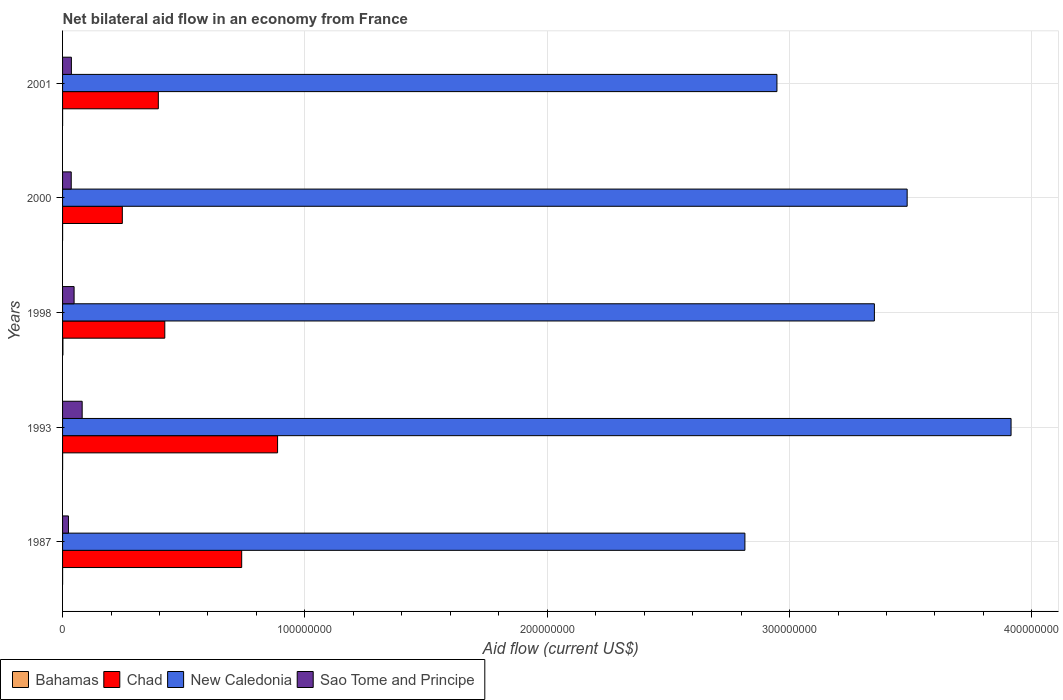How many different coloured bars are there?
Provide a succinct answer. 4. Are the number of bars on each tick of the Y-axis equal?
Make the answer very short. Yes. How many bars are there on the 5th tick from the bottom?
Provide a short and direct response. 4. In how many cases, is the number of bars for a given year not equal to the number of legend labels?
Offer a terse response. 0. What is the net bilateral aid flow in Chad in 2001?
Keep it short and to the point. 3.95e+07. Across all years, what is the maximum net bilateral aid flow in Sao Tome and Principe?
Offer a terse response. 8.09e+06. In which year was the net bilateral aid flow in Bahamas maximum?
Make the answer very short. 1998. What is the total net bilateral aid flow in Sao Tome and Principe in the graph?
Your answer should be very brief. 2.25e+07. What is the difference between the net bilateral aid flow in New Caledonia in 1993 and that in 1998?
Provide a short and direct response. 5.64e+07. What is the difference between the net bilateral aid flow in Chad in 1993 and the net bilateral aid flow in Bahamas in 2000?
Give a very brief answer. 8.87e+07. In the year 1993, what is the difference between the net bilateral aid flow in Chad and net bilateral aid flow in New Caledonia?
Give a very brief answer. -3.03e+08. What is the ratio of the net bilateral aid flow in Sao Tome and Principe in 1998 to that in 2000?
Offer a very short reply. 1.33. Is the net bilateral aid flow in Sao Tome and Principe in 1987 less than that in 1993?
Provide a short and direct response. Yes. What is the difference between the highest and the second highest net bilateral aid flow in Bahamas?
Make the answer very short. 1.30e+05. What is the difference between the highest and the lowest net bilateral aid flow in Sao Tome and Principe?
Make the answer very short. 5.66e+06. Is it the case that in every year, the sum of the net bilateral aid flow in Chad and net bilateral aid flow in New Caledonia is greater than the sum of net bilateral aid flow in Sao Tome and Principe and net bilateral aid flow in Bahamas?
Your answer should be compact. No. What does the 4th bar from the top in 1987 represents?
Offer a very short reply. Bahamas. What does the 4th bar from the bottom in 2001 represents?
Your response must be concise. Sao Tome and Principe. Is it the case that in every year, the sum of the net bilateral aid flow in Chad and net bilateral aid flow in New Caledonia is greater than the net bilateral aid flow in Bahamas?
Provide a succinct answer. Yes. How many bars are there?
Ensure brevity in your answer.  20. How many years are there in the graph?
Keep it short and to the point. 5. Are the values on the major ticks of X-axis written in scientific E-notation?
Your answer should be compact. No. How are the legend labels stacked?
Your response must be concise. Horizontal. What is the title of the graph?
Your answer should be very brief. Net bilateral aid flow in an economy from France. What is the Aid flow (current US$) in Chad in 1987?
Your answer should be very brief. 7.39e+07. What is the Aid flow (current US$) in New Caledonia in 1987?
Keep it short and to the point. 2.82e+08. What is the Aid flow (current US$) of Sao Tome and Principe in 1987?
Ensure brevity in your answer.  2.43e+06. What is the Aid flow (current US$) of Chad in 1993?
Your answer should be compact. 8.87e+07. What is the Aid flow (current US$) of New Caledonia in 1993?
Provide a succinct answer. 3.91e+08. What is the Aid flow (current US$) in Sao Tome and Principe in 1993?
Keep it short and to the point. 8.09e+06. What is the Aid flow (current US$) of Chad in 1998?
Provide a succinct answer. 4.22e+07. What is the Aid flow (current US$) in New Caledonia in 1998?
Ensure brevity in your answer.  3.35e+08. What is the Aid flow (current US$) in Sao Tome and Principe in 1998?
Keep it short and to the point. 4.76e+06. What is the Aid flow (current US$) in Chad in 2000?
Make the answer very short. 2.47e+07. What is the Aid flow (current US$) in New Caledonia in 2000?
Provide a short and direct response. 3.49e+08. What is the Aid flow (current US$) in Sao Tome and Principe in 2000?
Provide a short and direct response. 3.58e+06. What is the Aid flow (current US$) of Bahamas in 2001?
Offer a very short reply. 10000. What is the Aid flow (current US$) in Chad in 2001?
Offer a very short reply. 3.95e+07. What is the Aid flow (current US$) in New Caledonia in 2001?
Make the answer very short. 2.95e+08. What is the Aid flow (current US$) in Sao Tome and Principe in 2001?
Offer a terse response. 3.64e+06. Across all years, what is the maximum Aid flow (current US$) of Bahamas?
Make the answer very short. 1.50e+05. Across all years, what is the maximum Aid flow (current US$) of Chad?
Offer a very short reply. 8.87e+07. Across all years, what is the maximum Aid flow (current US$) in New Caledonia?
Keep it short and to the point. 3.91e+08. Across all years, what is the maximum Aid flow (current US$) of Sao Tome and Principe?
Your answer should be compact. 8.09e+06. Across all years, what is the minimum Aid flow (current US$) in Bahamas?
Provide a succinct answer. 10000. Across all years, what is the minimum Aid flow (current US$) of Chad?
Your response must be concise. 2.47e+07. Across all years, what is the minimum Aid flow (current US$) in New Caledonia?
Provide a succinct answer. 2.82e+08. Across all years, what is the minimum Aid flow (current US$) in Sao Tome and Principe?
Provide a succinct answer. 2.43e+06. What is the total Aid flow (current US$) in Bahamas in the graph?
Offer a terse response. 2.00e+05. What is the total Aid flow (current US$) of Chad in the graph?
Give a very brief answer. 2.69e+08. What is the total Aid flow (current US$) in New Caledonia in the graph?
Provide a short and direct response. 1.65e+09. What is the total Aid flow (current US$) in Sao Tome and Principe in the graph?
Your response must be concise. 2.25e+07. What is the difference between the Aid flow (current US$) of Chad in 1987 and that in 1993?
Provide a succinct answer. -1.48e+07. What is the difference between the Aid flow (current US$) of New Caledonia in 1987 and that in 1993?
Provide a short and direct response. -1.10e+08. What is the difference between the Aid flow (current US$) of Sao Tome and Principe in 1987 and that in 1993?
Provide a short and direct response. -5.66e+06. What is the difference between the Aid flow (current US$) of Bahamas in 1987 and that in 1998?
Offer a very short reply. -1.40e+05. What is the difference between the Aid flow (current US$) in Chad in 1987 and that in 1998?
Ensure brevity in your answer.  3.17e+07. What is the difference between the Aid flow (current US$) in New Caledonia in 1987 and that in 1998?
Ensure brevity in your answer.  -5.34e+07. What is the difference between the Aid flow (current US$) in Sao Tome and Principe in 1987 and that in 1998?
Keep it short and to the point. -2.33e+06. What is the difference between the Aid flow (current US$) of Chad in 1987 and that in 2000?
Your answer should be very brief. 4.93e+07. What is the difference between the Aid flow (current US$) in New Caledonia in 1987 and that in 2000?
Provide a short and direct response. -6.70e+07. What is the difference between the Aid flow (current US$) of Sao Tome and Principe in 1987 and that in 2000?
Keep it short and to the point. -1.15e+06. What is the difference between the Aid flow (current US$) in Chad in 1987 and that in 2001?
Ensure brevity in your answer.  3.44e+07. What is the difference between the Aid flow (current US$) of New Caledonia in 1987 and that in 2001?
Offer a very short reply. -1.32e+07. What is the difference between the Aid flow (current US$) of Sao Tome and Principe in 1987 and that in 2001?
Offer a terse response. -1.21e+06. What is the difference between the Aid flow (current US$) of Bahamas in 1993 and that in 1998?
Offer a very short reply. -1.30e+05. What is the difference between the Aid flow (current US$) in Chad in 1993 and that in 1998?
Make the answer very short. 4.65e+07. What is the difference between the Aid flow (current US$) of New Caledonia in 1993 and that in 1998?
Keep it short and to the point. 5.64e+07. What is the difference between the Aid flow (current US$) in Sao Tome and Principe in 1993 and that in 1998?
Provide a short and direct response. 3.33e+06. What is the difference between the Aid flow (current US$) in Bahamas in 1993 and that in 2000?
Make the answer very short. 10000. What is the difference between the Aid flow (current US$) of Chad in 1993 and that in 2000?
Ensure brevity in your answer.  6.41e+07. What is the difference between the Aid flow (current US$) of New Caledonia in 1993 and that in 2000?
Provide a succinct answer. 4.29e+07. What is the difference between the Aid flow (current US$) of Sao Tome and Principe in 1993 and that in 2000?
Make the answer very short. 4.51e+06. What is the difference between the Aid flow (current US$) in Bahamas in 1993 and that in 2001?
Offer a very short reply. 10000. What is the difference between the Aid flow (current US$) in Chad in 1993 and that in 2001?
Provide a short and direct response. 4.92e+07. What is the difference between the Aid flow (current US$) in New Caledonia in 1993 and that in 2001?
Keep it short and to the point. 9.66e+07. What is the difference between the Aid flow (current US$) in Sao Tome and Principe in 1993 and that in 2001?
Give a very brief answer. 4.45e+06. What is the difference between the Aid flow (current US$) of Chad in 1998 and that in 2000?
Provide a succinct answer. 1.75e+07. What is the difference between the Aid flow (current US$) in New Caledonia in 1998 and that in 2000?
Offer a very short reply. -1.35e+07. What is the difference between the Aid flow (current US$) in Sao Tome and Principe in 1998 and that in 2000?
Your answer should be compact. 1.18e+06. What is the difference between the Aid flow (current US$) of Bahamas in 1998 and that in 2001?
Provide a short and direct response. 1.40e+05. What is the difference between the Aid flow (current US$) in Chad in 1998 and that in 2001?
Provide a short and direct response. 2.67e+06. What is the difference between the Aid flow (current US$) of New Caledonia in 1998 and that in 2001?
Your answer should be compact. 4.02e+07. What is the difference between the Aid flow (current US$) in Sao Tome and Principe in 1998 and that in 2001?
Your response must be concise. 1.12e+06. What is the difference between the Aid flow (current US$) in Chad in 2000 and that in 2001?
Ensure brevity in your answer.  -1.49e+07. What is the difference between the Aid flow (current US$) of New Caledonia in 2000 and that in 2001?
Your answer should be very brief. 5.37e+07. What is the difference between the Aid flow (current US$) in Sao Tome and Principe in 2000 and that in 2001?
Make the answer very short. -6.00e+04. What is the difference between the Aid flow (current US$) in Bahamas in 1987 and the Aid flow (current US$) in Chad in 1993?
Give a very brief answer. -8.87e+07. What is the difference between the Aid flow (current US$) of Bahamas in 1987 and the Aid flow (current US$) of New Caledonia in 1993?
Keep it short and to the point. -3.91e+08. What is the difference between the Aid flow (current US$) in Bahamas in 1987 and the Aid flow (current US$) in Sao Tome and Principe in 1993?
Ensure brevity in your answer.  -8.08e+06. What is the difference between the Aid flow (current US$) in Chad in 1987 and the Aid flow (current US$) in New Caledonia in 1993?
Make the answer very short. -3.18e+08. What is the difference between the Aid flow (current US$) of Chad in 1987 and the Aid flow (current US$) of Sao Tome and Principe in 1993?
Your response must be concise. 6.58e+07. What is the difference between the Aid flow (current US$) in New Caledonia in 1987 and the Aid flow (current US$) in Sao Tome and Principe in 1993?
Offer a very short reply. 2.73e+08. What is the difference between the Aid flow (current US$) of Bahamas in 1987 and the Aid flow (current US$) of Chad in 1998?
Make the answer very short. -4.22e+07. What is the difference between the Aid flow (current US$) of Bahamas in 1987 and the Aid flow (current US$) of New Caledonia in 1998?
Ensure brevity in your answer.  -3.35e+08. What is the difference between the Aid flow (current US$) in Bahamas in 1987 and the Aid flow (current US$) in Sao Tome and Principe in 1998?
Your response must be concise. -4.75e+06. What is the difference between the Aid flow (current US$) of Chad in 1987 and the Aid flow (current US$) of New Caledonia in 1998?
Give a very brief answer. -2.61e+08. What is the difference between the Aid flow (current US$) of Chad in 1987 and the Aid flow (current US$) of Sao Tome and Principe in 1998?
Your response must be concise. 6.92e+07. What is the difference between the Aid flow (current US$) of New Caledonia in 1987 and the Aid flow (current US$) of Sao Tome and Principe in 1998?
Offer a terse response. 2.77e+08. What is the difference between the Aid flow (current US$) of Bahamas in 1987 and the Aid flow (current US$) of Chad in 2000?
Your response must be concise. -2.46e+07. What is the difference between the Aid flow (current US$) in Bahamas in 1987 and the Aid flow (current US$) in New Caledonia in 2000?
Your answer should be compact. -3.49e+08. What is the difference between the Aid flow (current US$) in Bahamas in 1987 and the Aid flow (current US$) in Sao Tome and Principe in 2000?
Provide a short and direct response. -3.57e+06. What is the difference between the Aid flow (current US$) in Chad in 1987 and the Aid flow (current US$) in New Caledonia in 2000?
Provide a short and direct response. -2.75e+08. What is the difference between the Aid flow (current US$) in Chad in 1987 and the Aid flow (current US$) in Sao Tome and Principe in 2000?
Your response must be concise. 7.03e+07. What is the difference between the Aid flow (current US$) in New Caledonia in 1987 and the Aid flow (current US$) in Sao Tome and Principe in 2000?
Keep it short and to the point. 2.78e+08. What is the difference between the Aid flow (current US$) of Bahamas in 1987 and the Aid flow (current US$) of Chad in 2001?
Ensure brevity in your answer.  -3.95e+07. What is the difference between the Aid flow (current US$) of Bahamas in 1987 and the Aid flow (current US$) of New Caledonia in 2001?
Ensure brevity in your answer.  -2.95e+08. What is the difference between the Aid flow (current US$) of Bahamas in 1987 and the Aid flow (current US$) of Sao Tome and Principe in 2001?
Give a very brief answer. -3.63e+06. What is the difference between the Aid flow (current US$) in Chad in 1987 and the Aid flow (current US$) in New Caledonia in 2001?
Ensure brevity in your answer.  -2.21e+08. What is the difference between the Aid flow (current US$) of Chad in 1987 and the Aid flow (current US$) of Sao Tome and Principe in 2001?
Give a very brief answer. 7.03e+07. What is the difference between the Aid flow (current US$) of New Caledonia in 1987 and the Aid flow (current US$) of Sao Tome and Principe in 2001?
Your response must be concise. 2.78e+08. What is the difference between the Aid flow (current US$) in Bahamas in 1993 and the Aid flow (current US$) in Chad in 1998?
Provide a succinct answer. -4.22e+07. What is the difference between the Aid flow (current US$) of Bahamas in 1993 and the Aid flow (current US$) of New Caledonia in 1998?
Give a very brief answer. -3.35e+08. What is the difference between the Aid flow (current US$) in Bahamas in 1993 and the Aid flow (current US$) in Sao Tome and Principe in 1998?
Your answer should be compact. -4.74e+06. What is the difference between the Aid flow (current US$) in Chad in 1993 and the Aid flow (current US$) in New Caledonia in 1998?
Ensure brevity in your answer.  -2.46e+08. What is the difference between the Aid flow (current US$) of Chad in 1993 and the Aid flow (current US$) of Sao Tome and Principe in 1998?
Your answer should be very brief. 8.40e+07. What is the difference between the Aid flow (current US$) of New Caledonia in 1993 and the Aid flow (current US$) of Sao Tome and Principe in 1998?
Offer a terse response. 3.87e+08. What is the difference between the Aid flow (current US$) in Bahamas in 1993 and the Aid flow (current US$) in Chad in 2000?
Give a very brief answer. -2.46e+07. What is the difference between the Aid flow (current US$) in Bahamas in 1993 and the Aid flow (current US$) in New Caledonia in 2000?
Offer a terse response. -3.49e+08. What is the difference between the Aid flow (current US$) in Bahamas in 1993 and the Aid flow (current US$) in Sao Tome and Principe in 2000?
Your answer should be very brief. -3.56e+06. What is the difference between the Aid flow (current US$) of Chad in 1993 and the Aid flow (current US$) of New Caledonia in 2000?
Your response must be concise. -2.60e+08. What is the difference between the Aid flow (current US$) of Chad in 1993 and the Aid flow (current US$) of Sao Tome and Principe in 2000?
Your answer should be very brief. 8.52e+07. What is the difference between the Aid flow (current US$) in New Caledonia in 1993 and the Aid flow (current US$) in Sao Tome and Principe in 2000?
Your response must be concise. 3.88e+08. What is the difference between the Aid flow (current US$) of Bahamas in 1993 and the Aid flow (current US$) of Chad in 2001?
Your answer should be compact. -3.95e+07. What is the difference between the Aid flow (current US$) of Bahamas in 1993 and the Aid flow (current US$) of New Caledonia in 2001?
Provide a succinct answer. -2.95e+08. What is the difference between the Aid flow (current US$) of Bahamas in 1993 and the Aid flow (current US$) of Sao Tome and Principe in 2001?
Offer a terse response. -3.62e+06. What is the difference between the Aid flow (current US$) of Chad in 1993 and the Aid flow (current US$) of New Caledonia in 2001?
Offer a terse response. -2.06e+08. What is the difference between the Aid flow (current US$) of Chad in 1993 and the Aid flow (current US$) of Sao Tome and Principe in 2001?
Your answer should be compact. 8.51e+07. What is the difference between the Aid flow (current US$) of New Caledonia in 1993 and the Aid flow (current US$) of Sao Tome and Principe in 2001?
Provide a short and direct response. 3.88e+08. What is the difference between the Aid flow (current US$) of Bahamas in 1998 and the Aid flow (current US$) of Chad in 2000?
Provide a succinct answer. -2.45e+07. What is the difference between the Aid flow (current US$) in Bahamas in 1998 and the Aid flow (current US$) in New Caledonia in 2000?
Your answer should be compact. -3.48e+08. What is the difference between the Aid flow (current US$) of Bahamas in 1998 and the Aid flow (current US$) of Sao Tome and Principe in 2000?
Your answer should be very brief. -3.43e+06. What is the difference between the Aid flow (current US$) of Chad in 1998 and the Aid flow (current US$) of New Caledonia in 2000?
Provide a succinct answer. -3.06e+08. What is the difference between the Aid flow (current US$) in Chad in 1998 and the Aid flow (current US$) in Sao Tome and Principe in 2000?
Offer a terse response. 3.86e+07. What is the difference between the Aid flow (current US$) in New Caledonia in 1998 and the Aid flow (current US$) in Sao Tome and Principe in 2000?
Your answer should be very brief. 3.31e+08. What is the difference between the Aid flow (current US$) of Bahamas in 1998 and the Aid flow (current US$) of Chad in 2001?
Ensure brevity in your answer.  -3.94e+07. What is the difference between the Aid flow (current US$) in Bahamas in 1998 and the Aid flow (current US$) in New Caledonia in 2001?
Offer a very short reply. -2.95e+08. What is the difference between the Aid flow (current US$) of Bahamas in 1998 and the Aid flow (current US$) of Sao Tome and Principe in 2001?
Ensure brevity in your answer.  -3.49e+06. What is the difference between the Aid flow (current US$) in Chad in 1998 and the Aid flow (current US$) in New Caledonia in 2001?
Keep it short and to the point. -2.53e+08. What is the difference between the Aid flow (current US$) of Chad in 1998 and the Aid flow (current US$) of Sao Tome and Principe in 2001?
Give a very brief answer. 3.86e+07. What is the difference between the Aid flow (current US$) in New Caledonia in 1998 and the Aid flow (current US$) in Sao Tome and Principe in 2001?
Provide a short and direct response. 3.31e+08. What is the difference between the Aid flow (current US$) in Bahamas in 2000 and the Aid flow (current US$) in Chad in 2001?
Provide a succinct answer. -3.95e+07. What is the difference between the Aid flow (current US$) in Bahamas in 2000 and the Aid flow (current US$) in New Caledonia in 2001?
Make the answer very short. -2.95e+08. What is the difference between the Aid flow (current US$) in Bahamas in 2000 and the Aid flow (current US$) in Sao Tome and Principe in 2001?
Make the answer very short. -3.63e+06. What is the difference between the Aid flow (current US$) of Chad in 2000 and the Aid flow (current US$) of New Caledonia in 2001?
Your response must be concise. -2.70e+08. What is the difference between the Aid flow (current US$) in Chad in 2000 and the Aid flow (current US$) in Sao Tome and Principe in 2001?
Give a very brief answer. 2.10e+07. What is the difference between the Aid flow (current US$) in New Caledonia in 2000 and the Aid flow (current US$) in Sao Tome and Principe in 2001?
Offer a terse response. 3.45e+08. What is the average Aid flow (current US$) in Bahamas per year?
Your answer should be very brief. 4.00e+04. What is the average Aid flow (current US$) in Chad per year?
Your response must be concise. 5.38e+07. What is the average Aid flow (current US$) of New Caledonia per year?
Keep it short and to the point. 3.30e+08. What is the average Aid flow (current US$) of Sao Tome and Principe per year?
Your response must be concise. 4.50e+06. In the year 1987, what is the difference between the Aid flow (current US$) in Bahamas and Aid flow (current US$) in Chad?
Your answer should be very brief. -7.39e+07. In the year 1987, what is the difference between the Aid flow (current US$) in Bahamas and Aid flow (current US$) in New Caledonia?
Give a very brief answer. -2.82e+08. In the year 1987, what is the difference between the Aid flow (current US$) in Bahamas and Aid flow (current US$) in Sao Tome and Principe?
Offer a very short reply. -2.42e+06. In the year 1987, what is the difference between the Aid flow (current US$) in Chad and Aid flow (current US$) in New Caledonia?
Give a very brief answer. -2.08e+08. In the year 1987, what is the difference between the Aid flow (current US$) of Chad and Aid flow (current US$) of Sao Tome and Principe?
Offer a very short reply. 7.15e+07. In the year 1987, what is the difference between the Aid flow (current US$) in New Caledonia and Aid flow (current US$) in Sao Tome and Principe?
Provide a succinct answer. 2.79e+08. In the year 1993, what is the difference between the Aid flow (current US$) in Bahamas and Aid flow (current US$) in Chad?
Provide a short and direct response. -8.87e+07. In the year 1993, what is the difference between the Aid flow (current US$) of Bahamas and Aid flow (current US$) of New Caledonia?
Make the answer very short. -3.91e+08. In the year 1993, what is the difference between the Aid flow (current US$) in Bahamas and Aid flow (current US$) in Sao Tome and Principe?
Your answer should be very brief. -8.07e+06. In the year 1993, what is the difference between the Aid flow (current US$) of Chad and Aid flow (current US$) of New Caledonia?
Offer a terse response. -3.03e+08. In the year 1993, what is the difference between the Aid flow (current US$) of Chad and Aid flow (current US$) of Sao Tome and Principe?
Provide a short and direct response. 8.06e+07. In the year 1993, what is the difference between the Aid flow (current US$) of New Caledonia and Aid flow (current US$) of Sao Tome and Principe?
Your answer should be very brief. 3.83e+08. In the year 1998, what is the difference between the Aid flow (current US$) of Bahamas and Aid flow (current US$) of Chad?
Your answer should be very brief. -4.20e+07. In the year 1998, what is the difference between the Aid flow (current US$) in Bahamas and Aid flow (current US$) in New Caledonia?
Offer a terse response. -3.35e+08. In the year 1998, what is the difference between the Aid flow (current US$) in Bahamas and Aid flow (current US$) in Sao Tome and Principe?
Offer a terse response. -4.61e+06. In the year 1998, what is the difference between the Aid flow (current US$) of Chad and Aid flow (current US$) of New Caledonia?
Your answer should be compact. -2.93e+08. In the year 1998, what is the difference between the Aid flow (current US$) of Chad and Aid flow (current US$) of Sao Tome and Principe?
Keep it short and to the point. 3.74e+07. In the year 1998, what is the difference between the Aid flow (current US$) of New Caledonia and Aid flow (current US$) of Sao Tome and Principe?
Make the answer very short. 3.30e+08. In the year 2000, what is the difference between the Aid flow (current US$) of Bahamas and Aid flow (current US$) of Chad?
Offer a terse response. -2.46e+07. In the year 2000, what is the difference between the Aid flow (current US$) of Bahamas and Aid flow (current US$) of New Caledonia?
Your answer should be very brief. -3.49e+08. In the year 2000, what is the difference between the Aid flow (current US$) in Bahamas and Aid flow (current US$) in Sao Tome and Principe?
Your answer should be very brief. -3.57e+06. In the year 2000, what is the difference between the Aid flow (current US$) in Chad and Aid flow (current US$) in New Caledonia?
Give a very brief answer. -3.24e+08. In the year 2000, what is the difference between the Aid flow (current US$) of Chad and Aid flow (current US$) of Sao Tome and Principe?
Give a very brief answer. 2.11e+07. In the year 2000, what is the difference between the Aid flow (current US$) of New Caledonia and Aid flow (current US$) of Sao Tome and Principe?
Ensure brevity in your answer.  3.45e+08. In the year 2001, what is the difference between the Aid flow (current US$) of Bahamas and Aid flow (current US$) of Chad?
Ensure brevity in your answer.  -3.95e+07. In the year 2001, what is the difference between the Aid flow (current US$) in Bahamas and Aid flow (current US$) in New Caledonia?
Provide a short and direct response. -2.95e+08. In the year 2001, what is the difference between the Aid flow (current US$) of Bahamas and Aid flow (current US$) of Sao Tome and Principe?
Your answer should be compact. -3.63e+06. In the year 2001, what is the difference between the Aid flow (current US$) of Chad and Aid flow (current US$) of New Caledonia?
Keep it short and to the point. -2.55e+08. In the year 2001, what is the difference between the Aid flow (current US$) of Chad and Aid flow (current US$) of Sao Tome and Principe?
Your answer should be very brief. 3.59e+07. In the year 2001, what is the difference between the Aid flow (current US$) in New Caledonia and Aid flow (current US$) in Sao Tome and Principe?
Offer a terse response. 2.91e+08. What is the ratio of the Aid flow (current US$) of Chad in 1987 to that in 1993?
Provide a short and direct response. 0.83. What is the ratio of the Aid flow (current US$) in New Caledonia in 1987 to that in 1993?
Your response must be concise. 0.72. What is the ratio of the Aid flow (current US$) in Sao Tome and Principe in 1987 to that in 1993?
Keep it short and to the point. 0.3. What is the ratio of the Aid flow (current US$) in Bahamas in 1987 to that in 1998?
Offer a terse response. 0.07. What is the ratio of the Aid flow (current US$) in Chad in 1987 to that in 1998?
Keep it short and to the point. 1.75. What is the ratio of the Aid flow (current US$) in New Caledonia in 1987 to that in 1998?
Make the answer very short. 0.84. What is the ratio of the Aid flow (current US$) of Sao Tome and Principe in 1987 to that in 1998?
Keep it short and to the point. 0.51. What is the ratio of the Aid flow (current US$) of Chad in 1987 to that in 2000?
Offer a terse response. 3. What is the ratio of the Aid flow (current US$) in New Caledonia in 1987 to that in 2000?
Give a very brief answer. 0.81. What is the ratio of the Aid flow (current US$) of Sao Tome and Principe in 1987 to that in 2000?
Ensure brevity in your answer.  0.68. What is the ratio of the Aid flow (current US$) in Bahamas in 1987 to that in 2001?
Your answer should be compact. 1. What is the ratio of the Aid flow (current US$) of Chad in 1987 to that in 2001?
Your answer should be very brief. 1.87. What is the ratio of the Aid flow (current US$) in New Caledonia in 1987 to that in 2001?
Offer a very short reply. 0.96. What is the ratio of the Aid flow (current US$) of Sao Tome and Principe in 1987 to that in 2001?
Provide a short and direct response. 0.67. What is the ratio of the Aid flow (current US$) of Bahamas in 1993 to that in 1998?
Offer a very short reply. 0.13. What is the ratio of the Aid flow (current US$) in Chad in 1993 to that in 1998?
Your answer should be compact. 2.1. What is the ratio of the Aid flow (current US$) in New Caledonia in 1993 to that in 1998?
Give a very brief answer. 1.17. What is the ratio of the Aid flow (current US$) in Sao Tome and Principe in 1993 to that in 1998?
Provide a succinct answer. 1.7. What is the ratio of the Aid flow (current US$) of Chad in 1993 to that in 2000?
Keep it short and to the point. 3.6. What is the ratio of the Aid flow (current US$) in New Caledonia in 1993 to that in 2000?
Ensure brevity in your answer.  1.12. What is the ratio of the Aid flow (current US$) in Sao Tome and Principe in 1993 to that in 2000?
Offer a very short reply. 2.26. What is the ratio of the Aid flow (current US$) of Chad in 1993 to that in 2001?
Make the answer very short. 2.25. What is the ratio of the Aid flow (current US$) in New Caledonia in 1993 to that in 2001?
Ensure brevity in your answer.  1.33. What is the ratio of the Aid flow (current US$) in Sao Tome and Principe in 1993 to that in 2001?
Keep it short and to the point. 2.22. What is the ratio of the Aid flow (current US$) of Bahamas in 1998 to that in 2000?
Make the answer very short. 15. What is the ratio of the Aid flow (current US$) in Chad in 1998 to that in 2000?
Provide a short and direct response. 1.71. What is the ratio of the Aid flow (current US$) in New Caledonia in 1998 to that in 2000?
Your answer should be compact. 0.96. What is the ratio of the Aid flow (current US$) in Sao Tome and Principe in 1998 to that in 2000?
Keep it short and to the point. 1.33. What is the ratio of the Aid flow (current US$) of Bahamas in 1998 to that in 2001?
Ensure brevity in your answer.  15. What is the ratio of the Aid flow (current US$) in Chad in 1998 to that in 2001?
Give a very brief answer. 1.07. What is the ratio of the Aid flow (current US$) in New Caledonia in 1998 to that in 2001?
Your answer should be very brief. 1.14. What is the ratio of the Aid flow (current US$) of Sao Tome and Principe in 1998 to that in 2001?
Make the answer very short. 1.31. What is the ratio of the Aid flow (current US$) in Chad in 2000 to that in 2001?
Ensure brevity in your answer.  0.62. What is the ratio of the Aid flow (current US$) in New Caledonia in 2000 to that in 2001?
Ensure brevity in your answer.  1.18. What is the ratio of the Aid flow (current US$) in Sao Tome and Principe in 2000 to that in 2001?
Keep it short and to the point. 0.98. What is the difference between the highest and the second highest Aid flow (current US$) in Bahamas?
Ensure brevity in your answer.  1.30e+05. What is the difference between the highest and the second highest Aid flow (current US$) of Chad?
Provide a succinct answer. 1.48e+07. What is the difference between the highest and the second highest Aid flow (current US$) of New Caledonia?
Your answer should be compact. 4.29e+07. What is the difference between the highest and the second highest Aid flow (current US$) of Sao Tome and Principe?
Provide a succinct answer. 3.33e+06. What is the difference between the highest and the lowest Aid flow (current US$) in Chad?
Provide a succinct answer. 6.41e+07. What is the difference between the highest and the lowest Aid flow (current US$) in New Caledonia?
Provide a short and direct response. 1.10e+08. What is the difference between the highest and the lowest Aid flow (current US$) in Sao Tome and Principe?
Your answer should be very brief. 5.66e+06. 